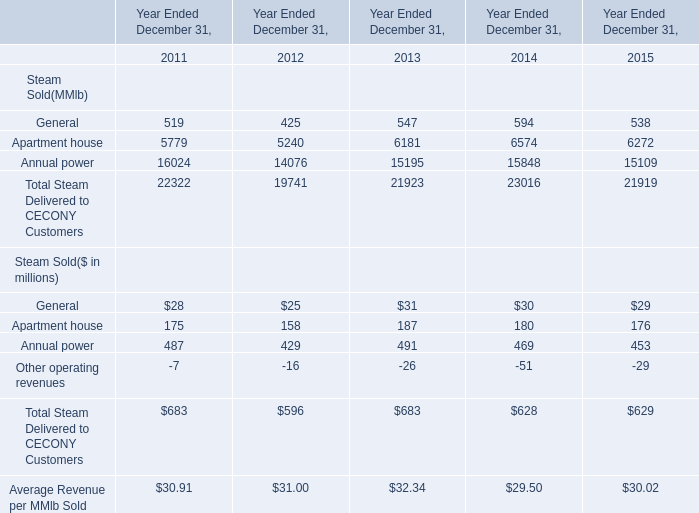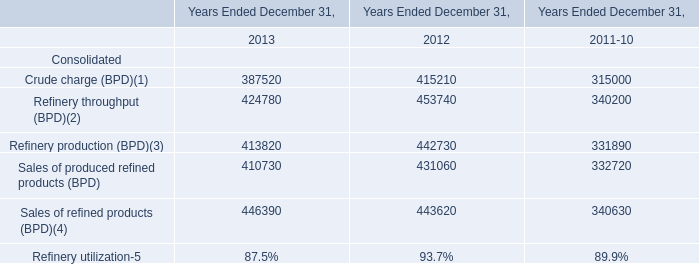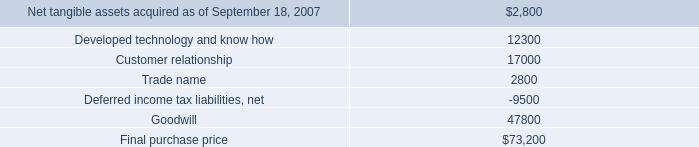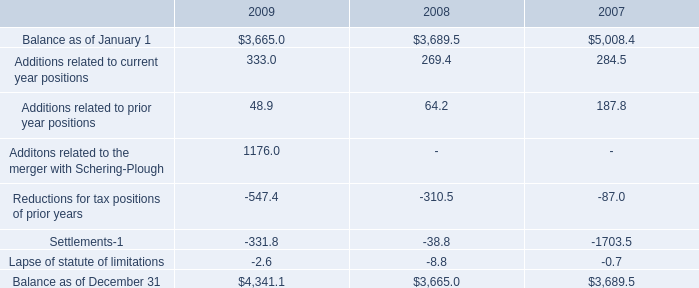What's the total amount of the elements in the years where General for Steam Sold(MMlb) greater than 590? 
Computations: ((594 + 6574) + 15848)
Answer: 23016.0. 